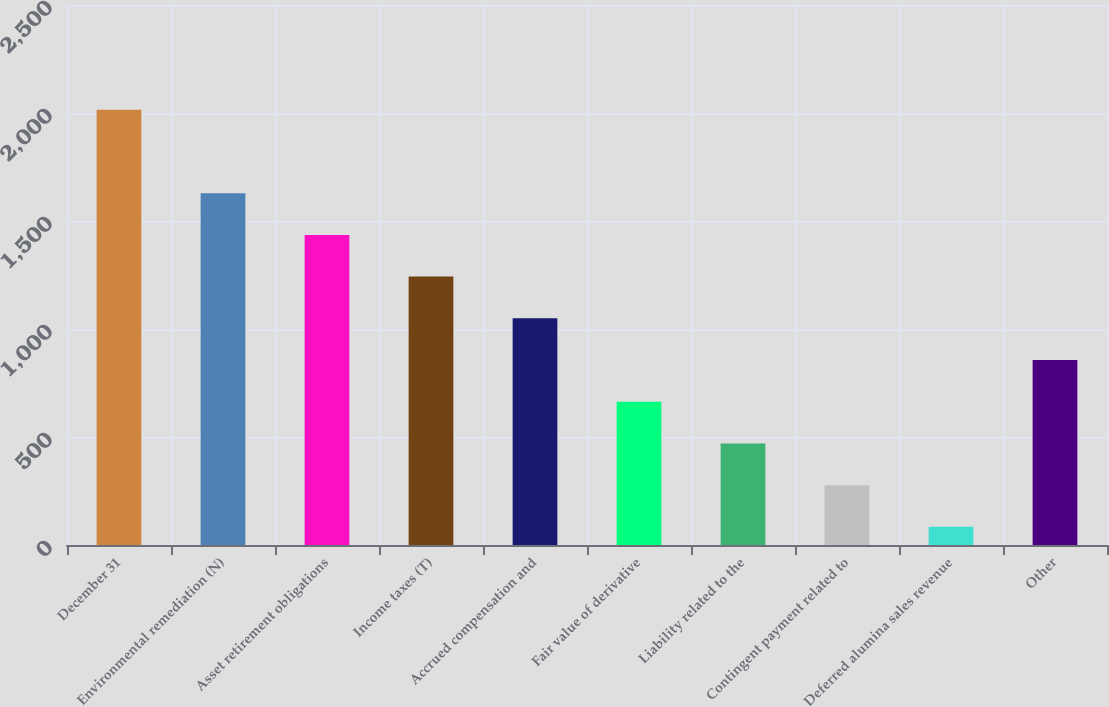<chart> <loc_0><loc_0><loc_500><loc_500><bar_chart><fcel>December 31<fcel>Environmental remediation (N)<fcel>Asset retirement obligations<fcel>Income taxes (T)<fcel>Accrued compensation and<fcel>Fair value of derivative<fcel>Liability related to the<fcel>Contingent payment related to<fcel>Deferred alumina sales revenue<fcel>Other<nl><fcel>2015<fcel>1628.8<fcel>1435.7<fcel>1242.6<fcel>1049.5<fcel>663.3<fcel>470.2<fcel>277.1<fcel>84<fcel>856.4<nl></chart> 